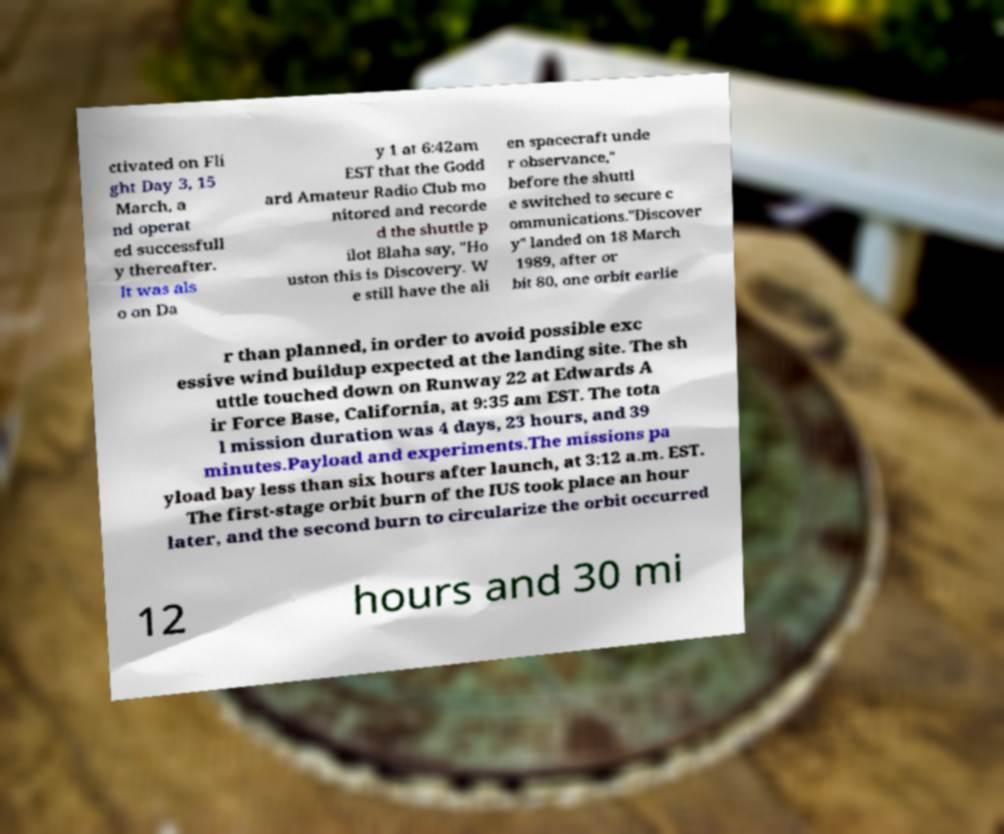Can you read and provide the text displayed in the image?This photo seems to have some interesting text. Can you extract and type it out for me? ctivated on Fli ght Day 3, 15 March, a nd operat ed successfull y thereafter. It was als o on Da y 1 at 6:42am EST that the Godd ard Amateur Radio Club mo nitored and recorde d the shuttle p ilot Blaha say, "Ho uston this is Discovery. W e still have the ali en spacecraft unde r observance," before the shuttl e switched to secure c ommunications."Discover y" landed on 18 March 1989, after or bit 80, one orbit earlie r than planned, in order to avoid possible exc essive wind buildup expected at the landing site. The sh uttle touched down on Runway 22 at Edwards A ir Force Base, California, at 9:35 am EST. The tota l mission duration was 4 days, 23 hours, and 39 minutes.Payload and experiments.The missions pa yload bay less than six hours after launch, at 3:12 a.m. EST. The first-stage orbit burn of the IUS took place an hour later, and the second burn to circularize the orbit occurred 12 hours and 30 mi 